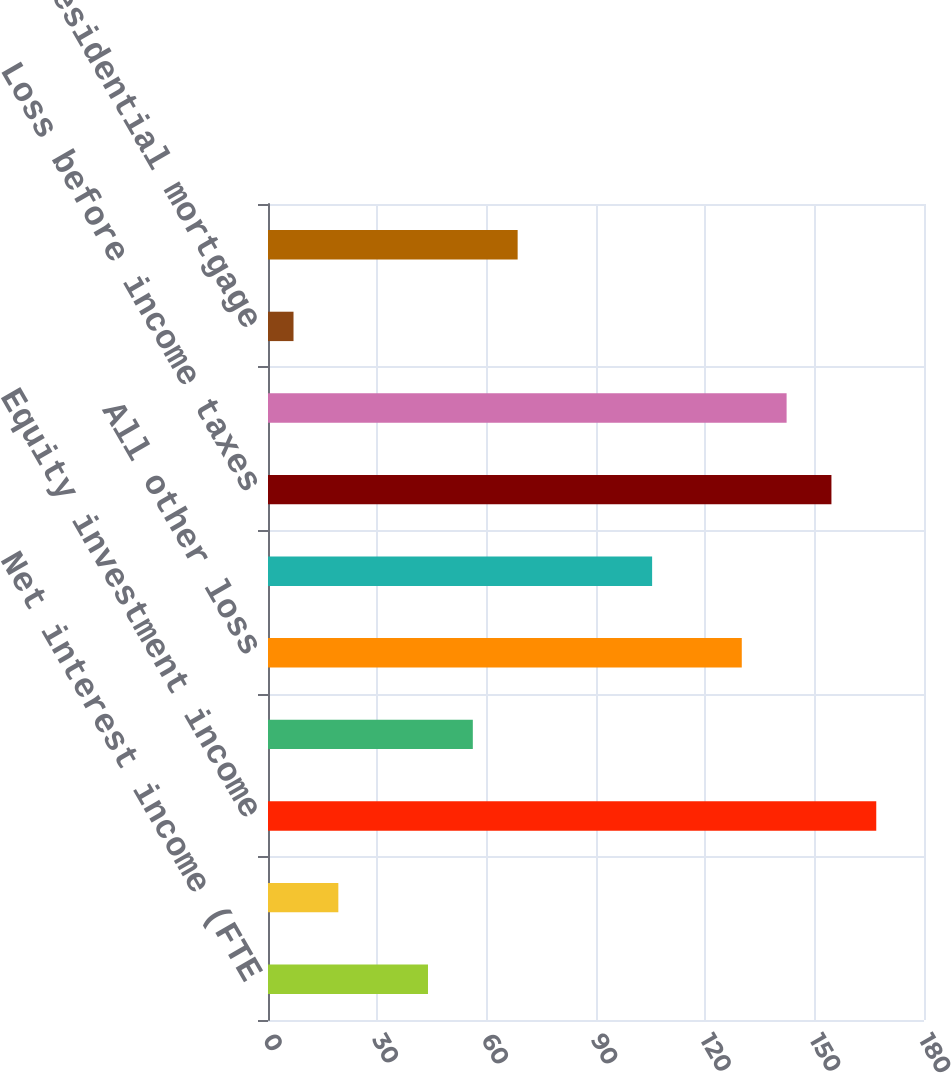<chart> <loc_0><loc_0><loc_500><loc_500><bar_chart><fcel>Net interest income (FTE<fcel>Card income<fcel>Equity investment income<fcel>Gains on sales of debt<fcel>All other loss<fcel>Noninterest expense<fcel>Loss before income taxes<fcel>Income tax benefit (FTE basis)<fcel>Residential mortgage<fcel>Non-US credit card<nl><fcel>43.9<fcel>19.3<fcel>166.9<fcel>56.2<fcel>130<fcel>105.4<fcel>154.6<fcel>142.3<fcel>7<fcel>68.5<nl></chart> 